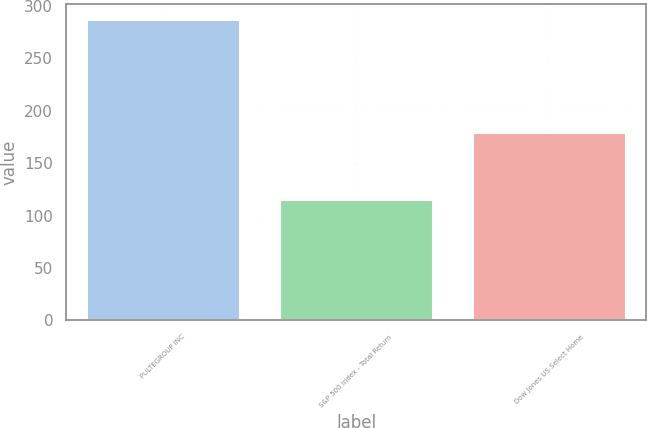Convert chart. <chart><loc_0><loc_0><loc_500><loc_500><bar_chart><fcel>PULTEGROUP INC<fcel>S&P 500 Index - Total Return<fcel>Dow Jones US Select Home<nl><fcel>287.8<fcel>116<fcel>179.68<nl></chart> 